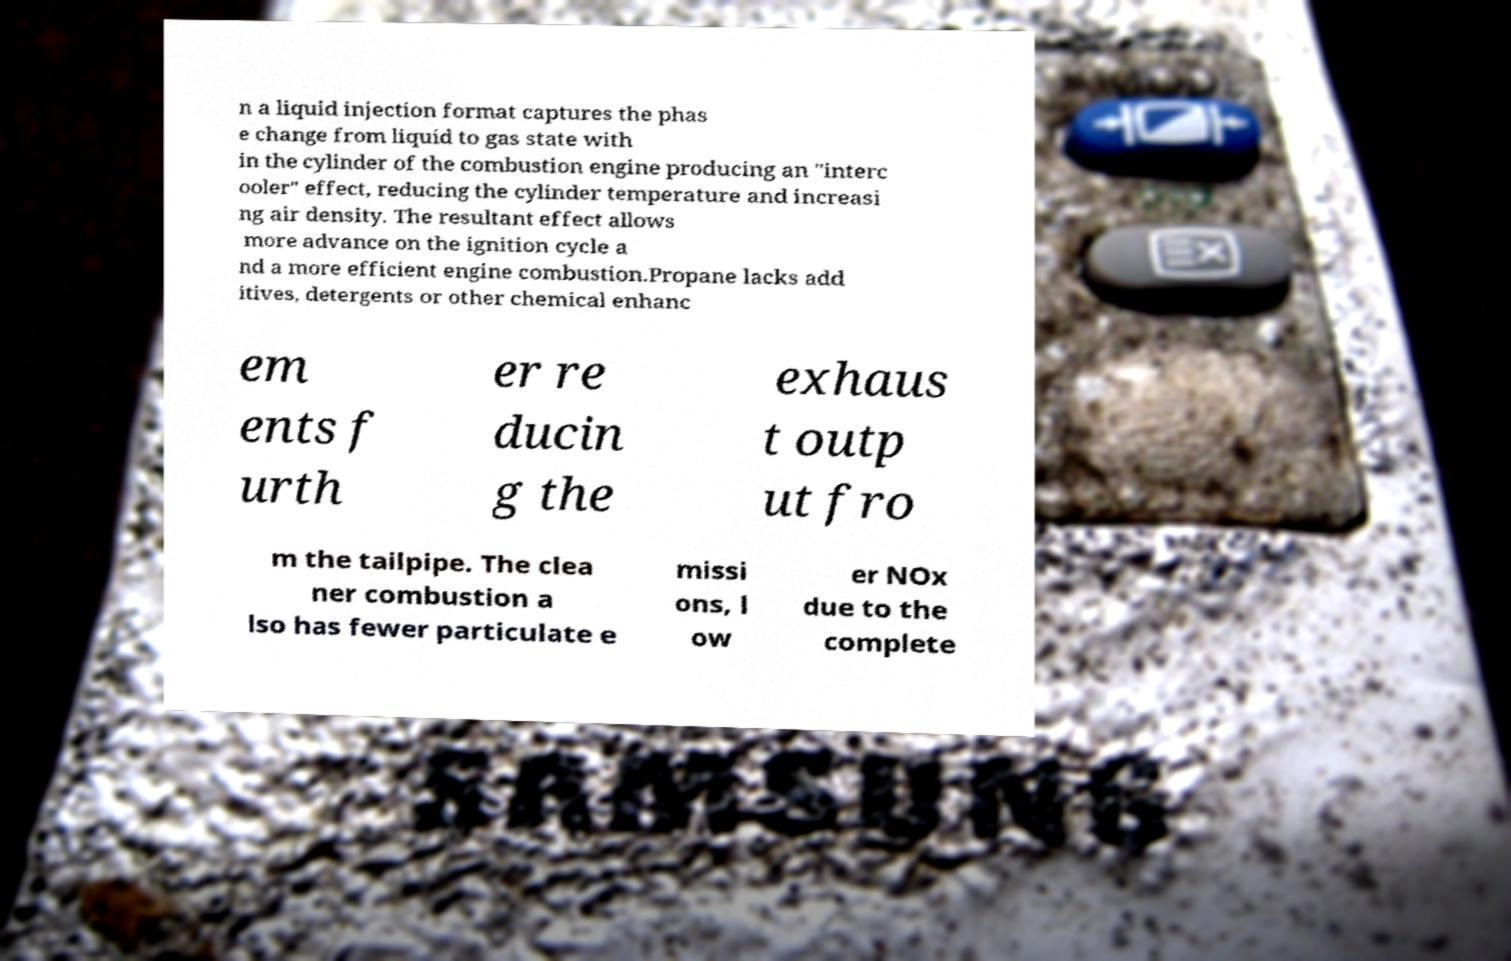Please identify and transcribe the text found in this image. n a liquid injection format captures the phas e change from liquid to gas state with in the cylinder of the combustion engine producing an "interc ooler" effect, reducing the cylinder temperature and increasi ng air density. The resultant effect allows more advance on the ignition cycle a nd a more efficient engine combustion.Propane lacks add itives, detergents or other chemical enhanc em ents f urth er re ducin g the exhaus t outp ut fro m the tailpipe. The clea ner combustion a lso has fewer particulate e missi ons, l ow er NOx due to the complete 